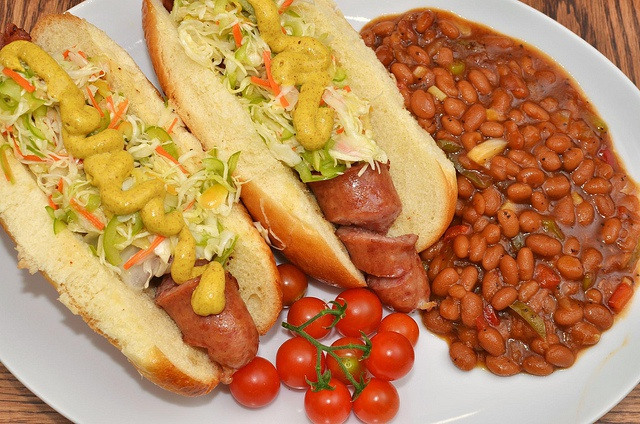Describe the objects in this image and their specific colors. I can see hot dog in brown, khaki, tan, and orange tones, hot dog in brown, khaki, tan, and orange tones, and dining table in brown and maroon tones in this image. 